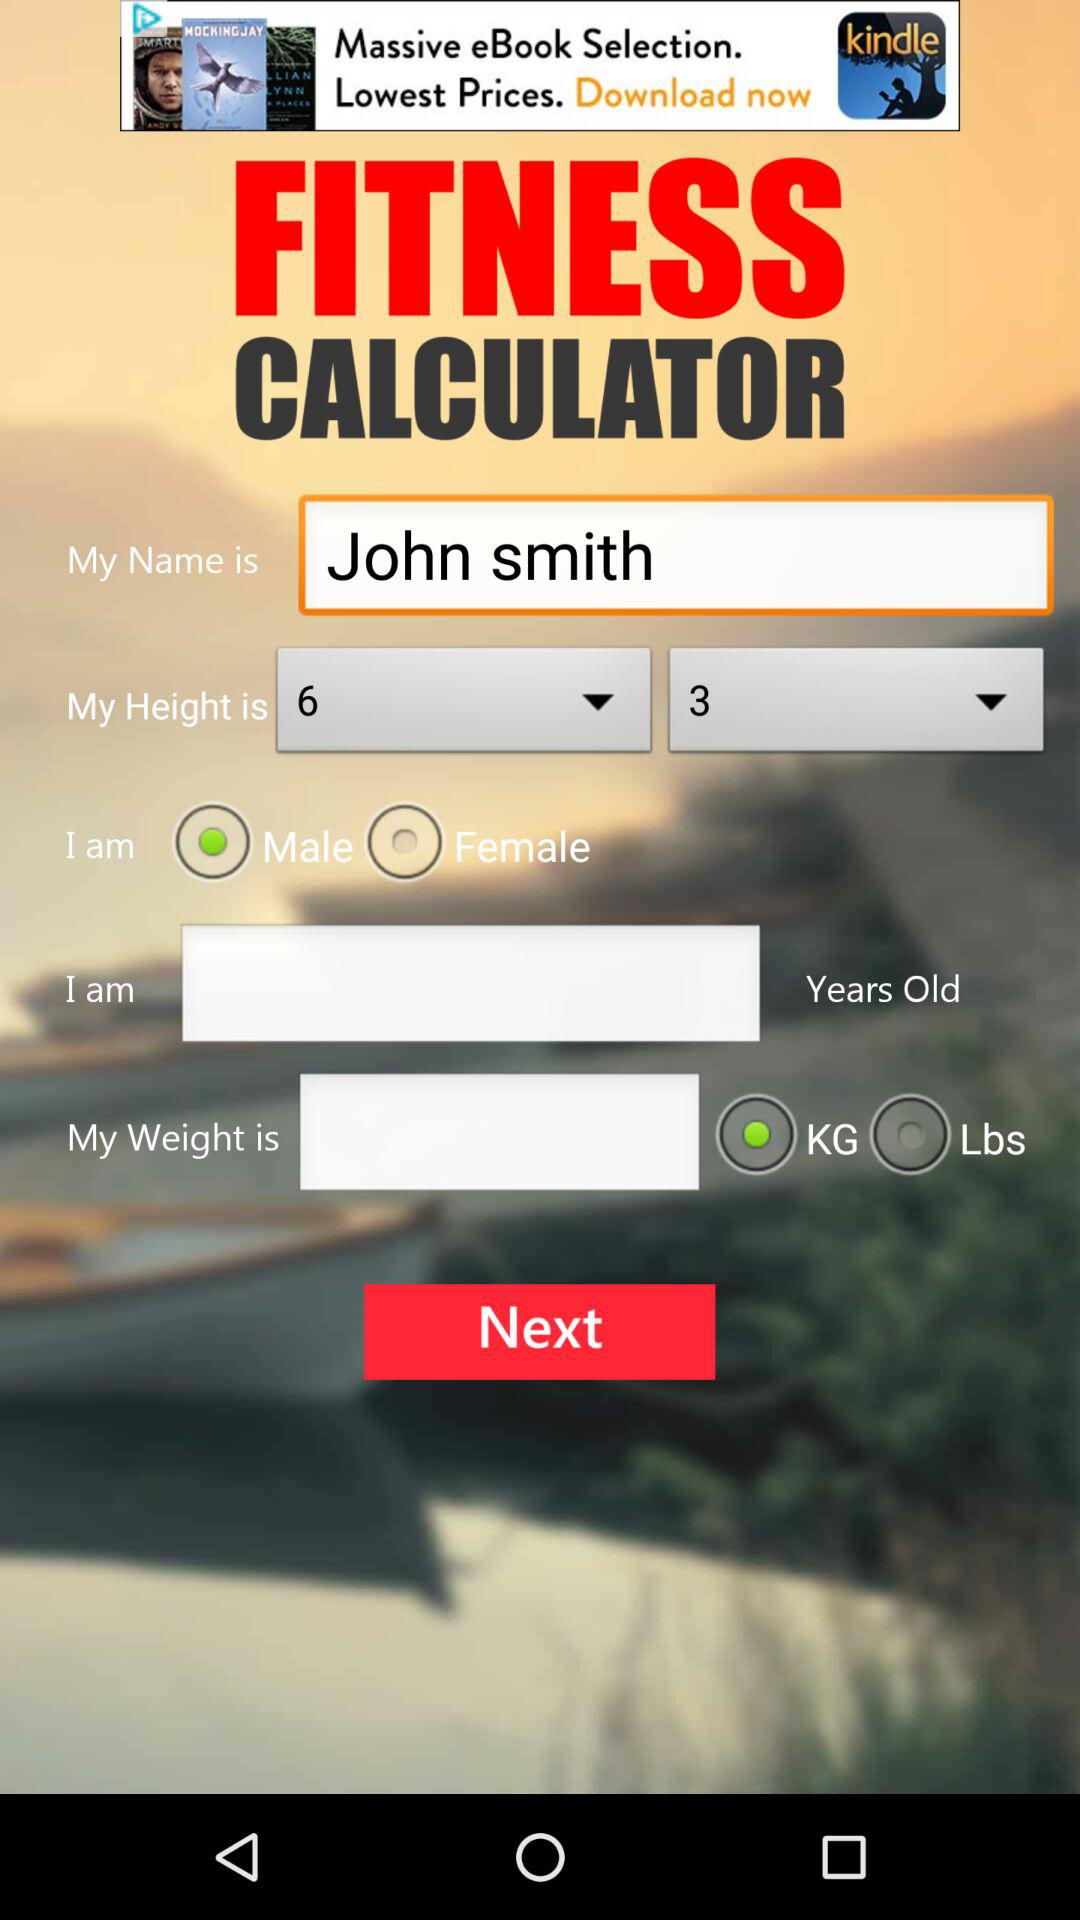What is "My Name"? "My Name" is "John smith". 